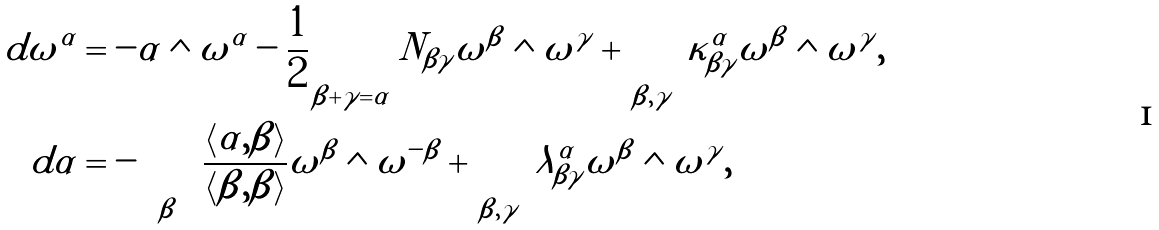<formula> <loc_0><loc_0><loc_500><loc_500>d \omega ^ { \alpha } & = - \alpha \wedge \omega ^ { \alpha } - \frac { 1 } { 2 } \sum _ { \beta + \gamma = \alpha } N _ { \beta \gamma } \omega ^ { \beta } \wedge \omega ^ { \gamma } + \sum _ { \beta , \gamma } \kappa ^ { \alpha } _ { \beta \gamma } \omega ^ { \beta } \wedge \omega ^ { \gamma } , \\ d \alpha & = - \sum _ { \beta } \frac { \left < \alpha , \beta \right > } { \left < \beta , \beta \right > } \omega ^ { \beta } \wedge \omega ^ { - \beta } + \sum _ { \beta , \gamma } \lambda ^ { \alpha } _ { \beta \gamma } \omega ^ { \beta } \wedge \omega ^ { \gamma } ,</formula> 